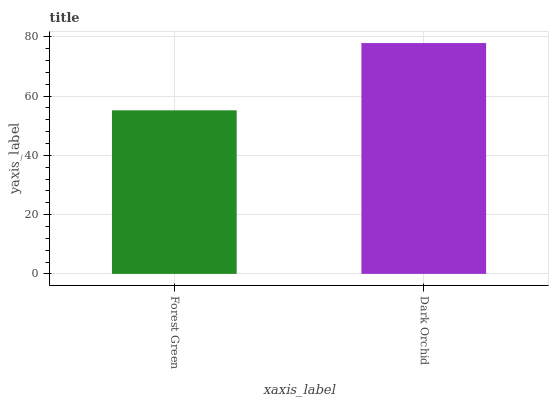Is Forest Green the minimum?
Answer yes or no. Yes. Is Dark Orchid the maximum?
Answer yes or no. Yes. Is Dark Orchid the minimum?
Answer yes or no. No. Is Dark Orchid greater than Forest Green?
Answer yes or no. Yes. Is Forest Green less than Dark Orchid?
Answer yes or no. Yes. Is Forest Green greater than Dark Orchid?
Answer yes or no. No. Is Dark Orchid less than Forest Green?
Answer yes or no. No. Is Dark Orchid the high median?
Answer yes or no. Yes. Is Forest Green the low median?
Answer yes or no. Yes. Is Forest Green the high median?
Answer yes or no. No. Is Dark Orchid the low median?
Answer yes or no. No. 